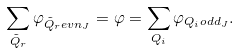Convert formula to latex. <formula><loc_0><loc_0><loc_500><loc_500>\sum _ { \tilde { Q } _ { r } } \varphi _ { \tilde { Q } _ { r } e v n _ { J } } = \varphi = \sum _ { Q _ { i } } \varphi _ { Q _ { i } o d d _ { J } } .</formula> 